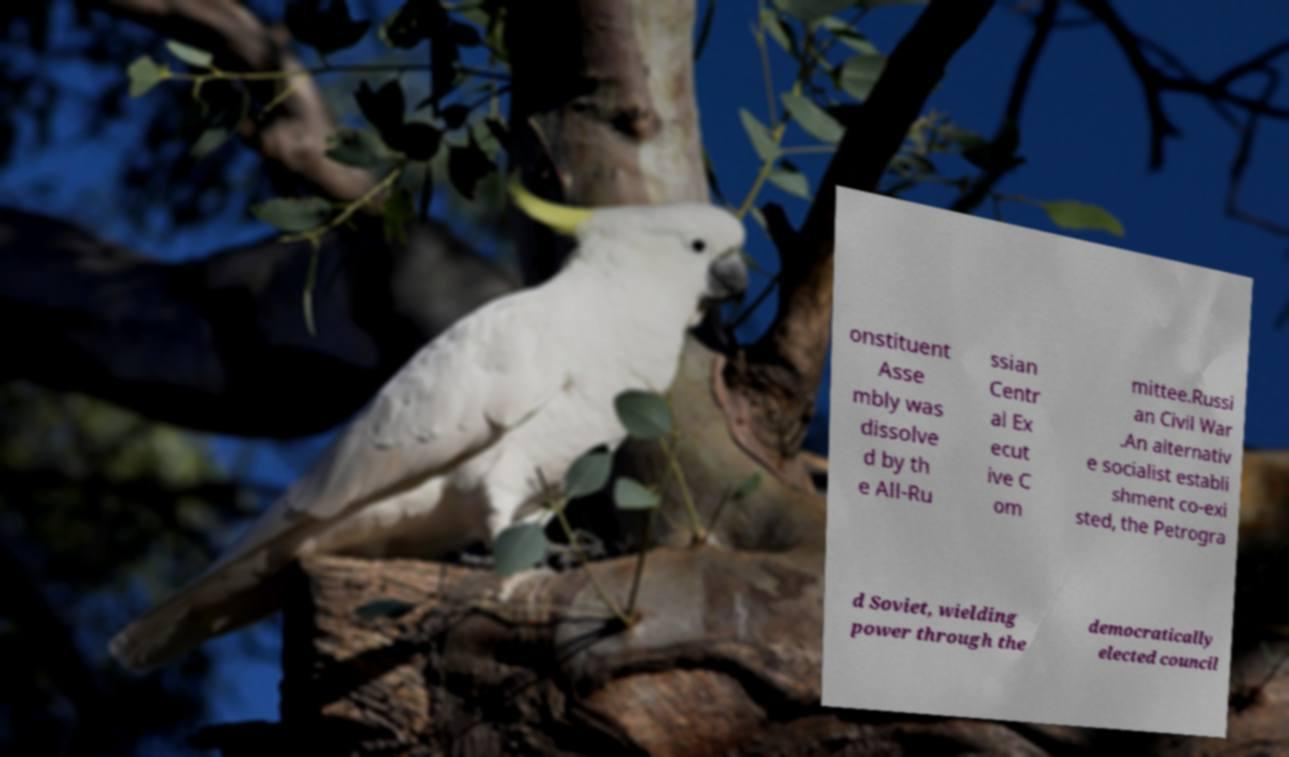For documentation purposes, I need the text within this image transcribed. Could you provide that? onstituent Asse mbly was dissolve d by th e All-Ru ssian Centr al Ex ecut ive C om mittee.Russi an Civil War .An alternativ e socialist establi shment co-exi sted, the Petrogra d Soviet, wielding power through the democratically elected council 